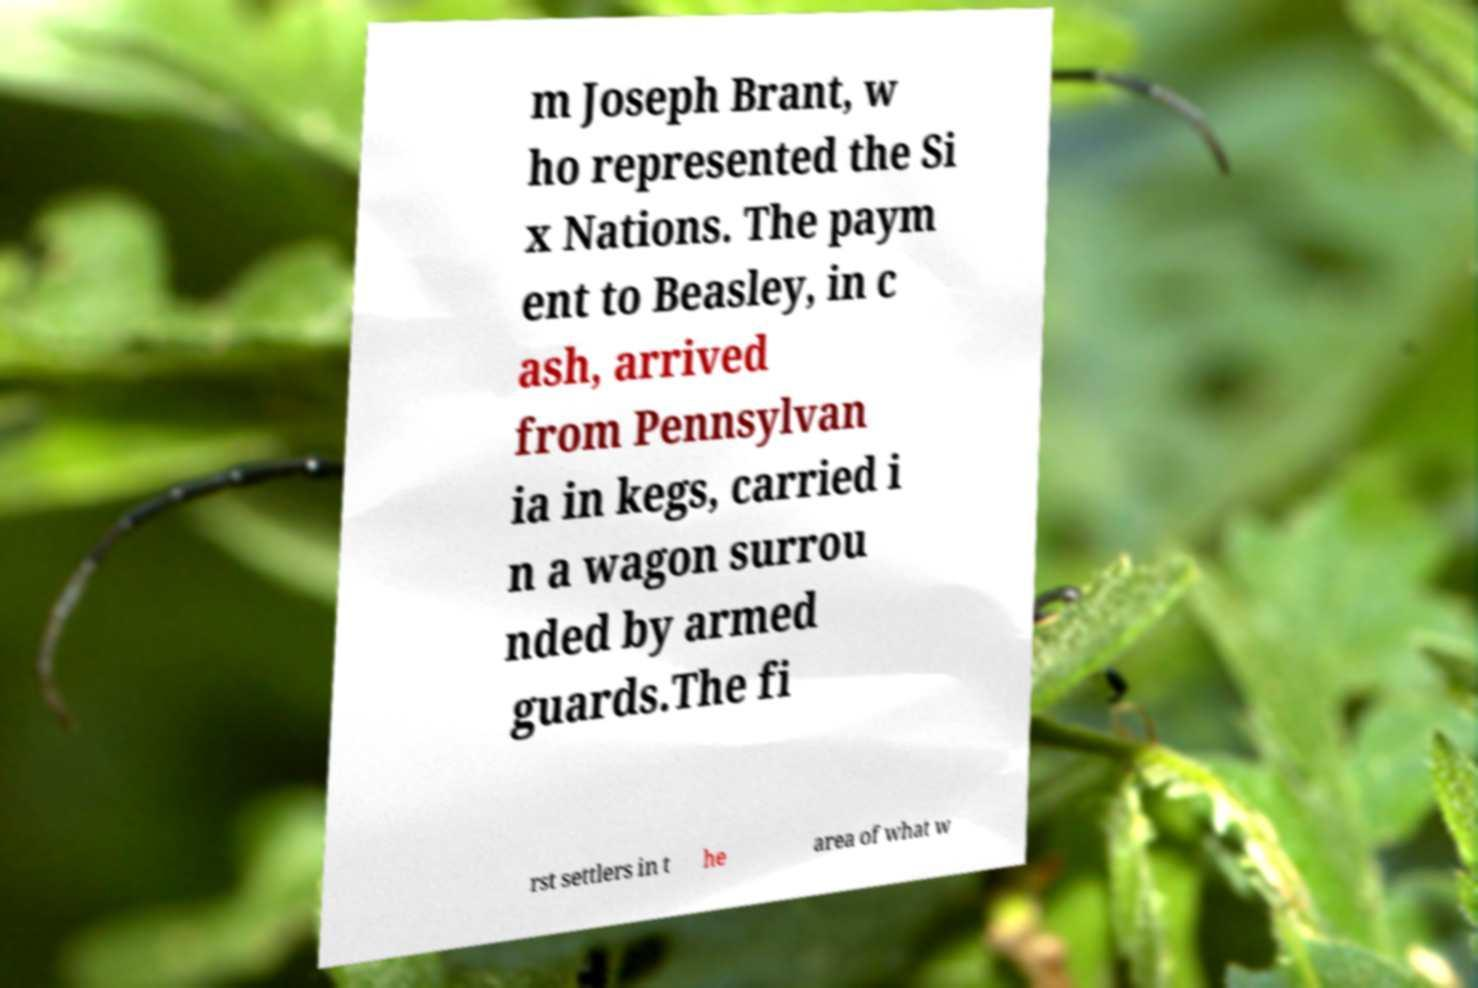Can you accurately transcribe the text from the provided image for me? m Joseph Brant, w ho represented the Si x Nations. The paym ent to Beasley, in c ash, arrived from Pennsylvan ia in kegs, carried i n a wagon surrou nded by armed guards.The fi rst settlers in t he area of what w 